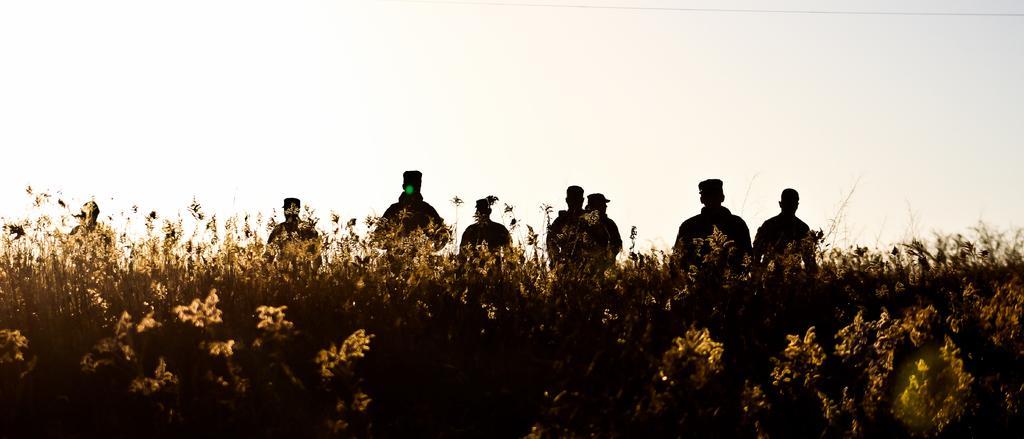In one or two sentences, can you explain what this image depicts? In this picture there are group of people standing. In the foreground there are plants. At the top there is sky. 